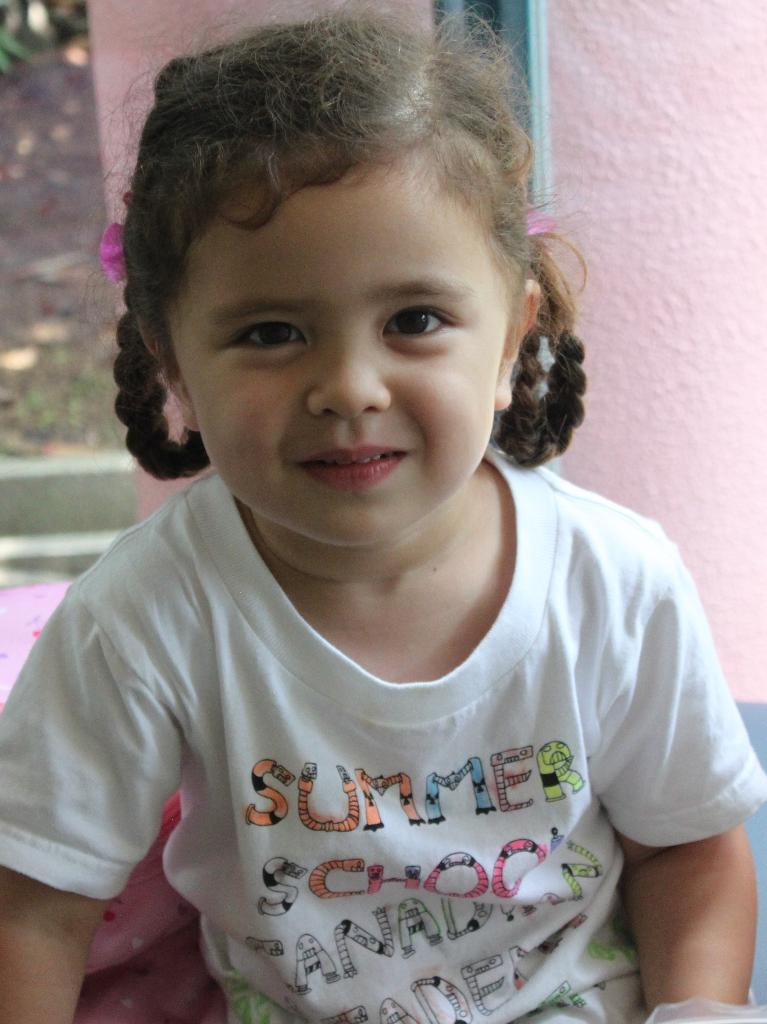Who is present in the image? There is a person in the image. What is the person wearing? The person is wearing a white dress. What is the person's facial expression? The person is smiling. What color is the wall in the background? The wall in the background is pink. What can be seen beneath the person's feet? The ground is visible in the image. What type of jewel can be seen on the person's forehead in the image? There is no jewel present on the person's forehead in the image. 